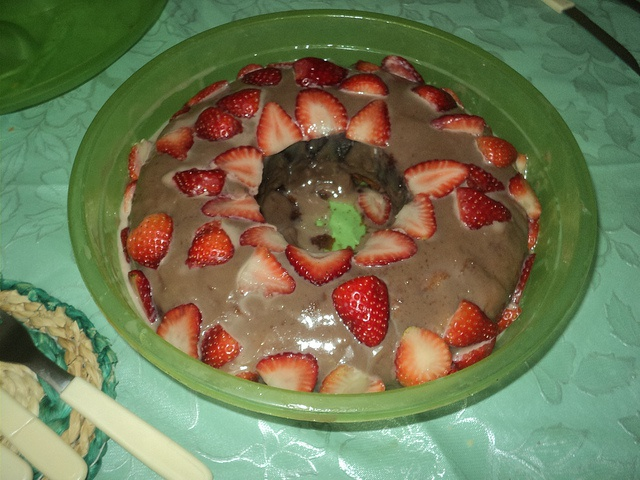Describe the objects in this image and their specific colors. I can see bowl in darkgreen, gray, maroon, and tan tones, cake in darkgreen, gray, maroon, and brown tones, fork in darkgreen, beige, black, gray, and darkgray tones, knife in darkgreen and black tones, and knife in black and darkgreen tones in this image. 